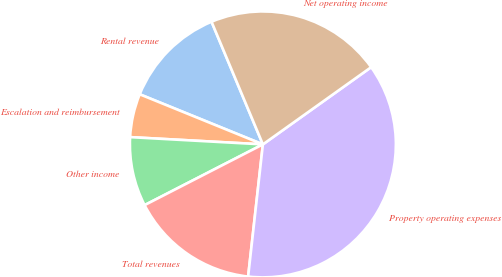Convert chart. <chart><loc_0><loc_0><loc_500><loc_500><pie_chart><fcel>Rental revenue<fcel>Escalation and reimbursement<fcel>Other income<fcel>Total revenues<fcel>Property operating expenses<fcel>Net operating income<nl><fcel>12.54%<fcel>5.28%<fcel>8.42%<fcel>15.68%<fcel>36.63%<fcel>21.45%<nl></chart> 